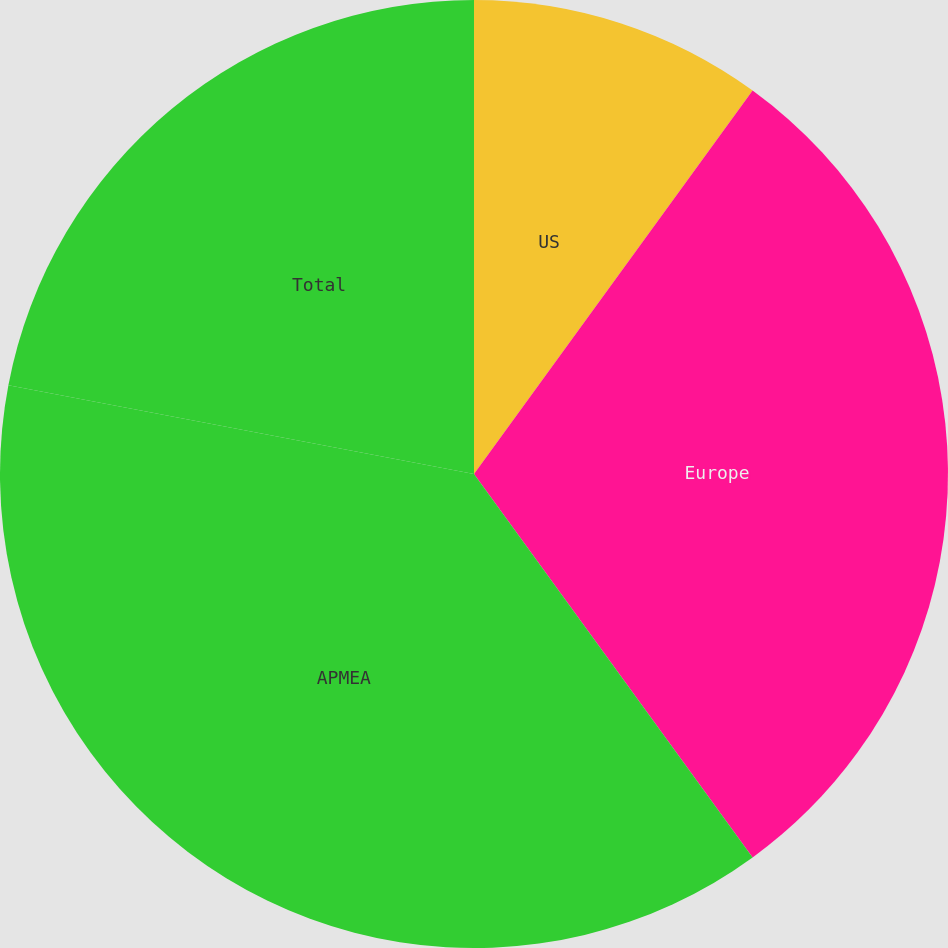<chart> <loc_0><loc_0><loc_500><loc_500><pie_chart><fcel>US<fcel>Europe<fcel>APMEA<fcel>Total<nl><fcel>10.0%<fcel>30.0%<fcel>38.0%<fcel>22.0%<nl></chart> 